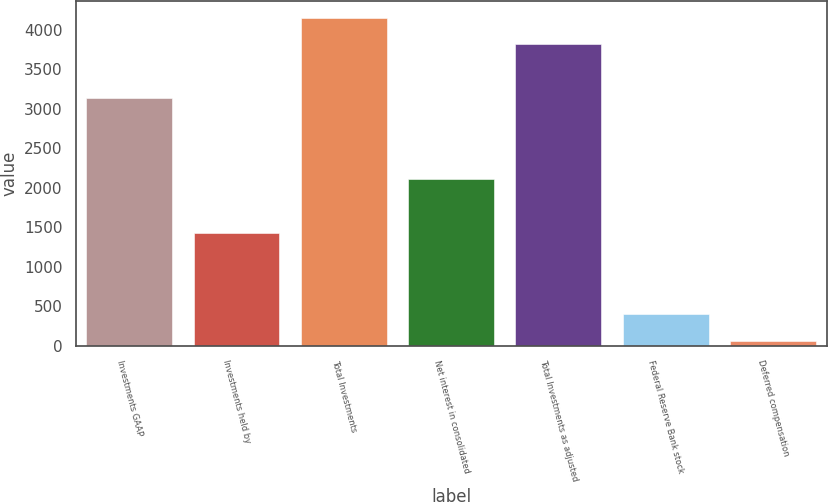<chart> <loc_0><loc_0><loc_500><loc_500><bar_chart><fcel>Investments GAAP<fcel>Investments held by<fcel>Total Investments<fcel>Net interest in consolidated<fcel>Total Investments as adjusted<fcel>Federal Reserve Bank stock<fcel>Deferred compensation<nl><fcel>3132.2<fcel>1423.2<fcel>4157.6<fcel>2106.8<fcel>3815.8<fcel>397.8<fcel>56<nl></chart> 